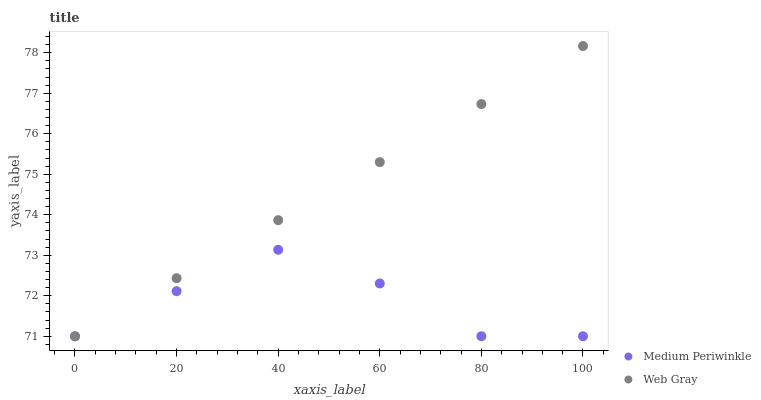Does Medium Periwinkle have the minimum area under the curve?
Answer yes or no. Yes. Does Web Gray have the maximum area under the curve?
Answer yes or no. Yes. Does Medium Periwinkle have the maximum area under the curve?
Answer yes or no. No. Is Web Gray the smoothest?
Answer yes or no. Yes. Is Medium Periwinkle the roughest?
Answer yes or no. Yes. Is Medium Periwinkle the smoothest?
Answer yes or no. No. Does Web Gray have the lowest value?
Answer yes or no. Yes. Does Web Gray have the highest value?
Answer yes or no. Yes. Does Medium Periwinkle have the highest value?
Answer yes or no. No. Does Medium Periwinkle intersect Web Gray?
Answer yes or no. Yes. Is Medium Periwinkle less than Web Gray?
Answer yes or no. No. Is Medium Periwinkle greater than Web Gray?
Answer yes or no. No. 